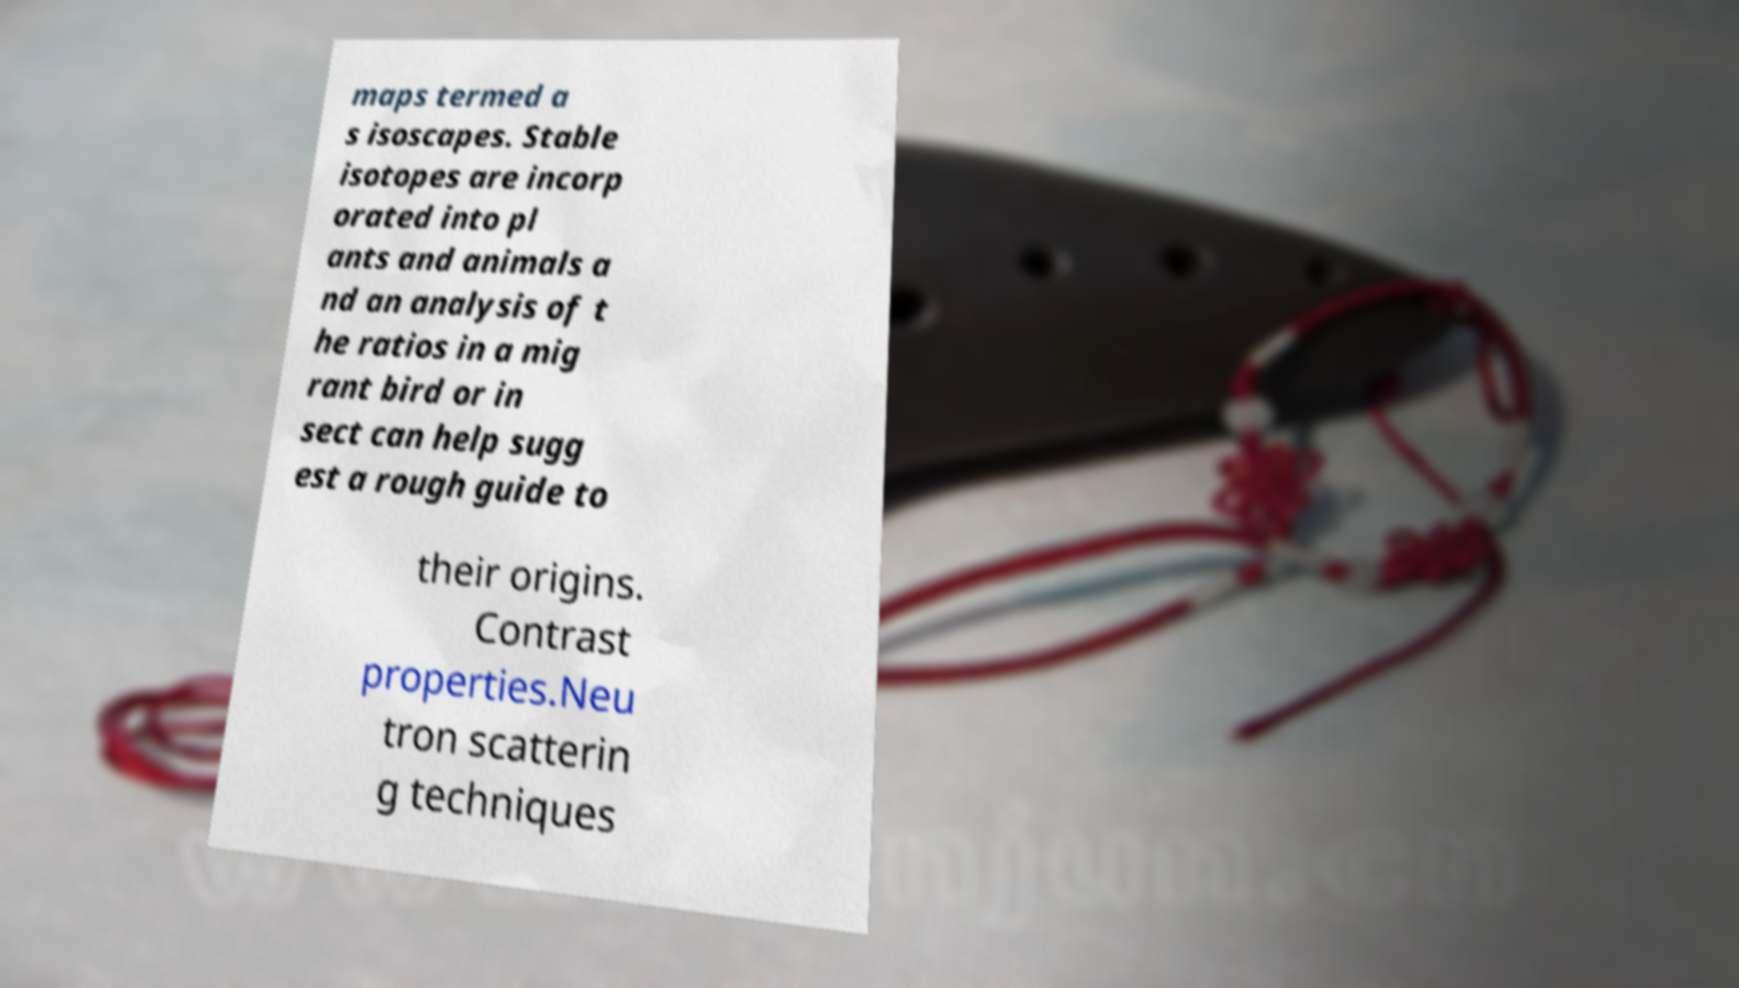There's text embedded in this image that I need extracted. Can you transcribe it verbatim? maps termed a s isoscapes. Stable isotopes are incorp orated into pl ants and animals a nd an analysis of t he ratios in a mig rant bird or in sect can help sugg est a rough guide to their origins. Contrast properties.Neu tron scatterin g techniques 